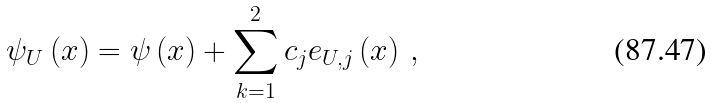<formula> <loc_0><loc_0><loc_500><loc_500>\psi _ { U } \left ( x \right ) = \psi \left ( x \right ) + \sum _ { k = 1 } ^ { 2 } c _ { j } e _ { U , j } \left ( x \right ) \, ,</formula> 